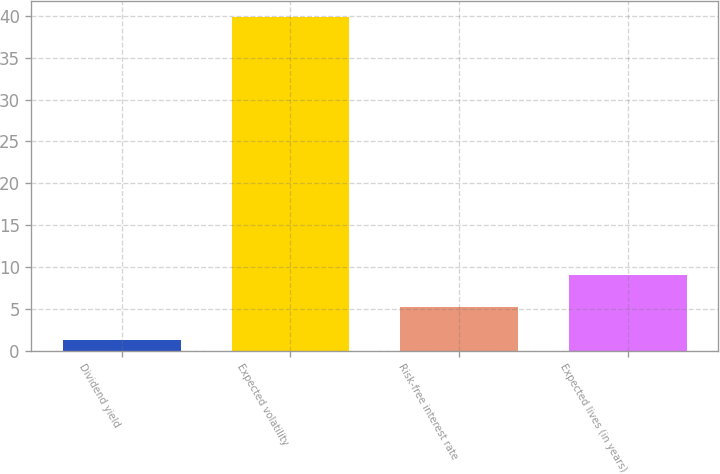<chart> <loc_0><loc_0><loc_500><loc_500><bar_chart><fcel>Dividend yield<fcel>Expected volatility<fcel>Risk-free interest rate<fcel>Expected lives (in years)<nl><fcel>1.33<fcel>39.84<fcel>5.18<fcel>9.03<nl></chart> 